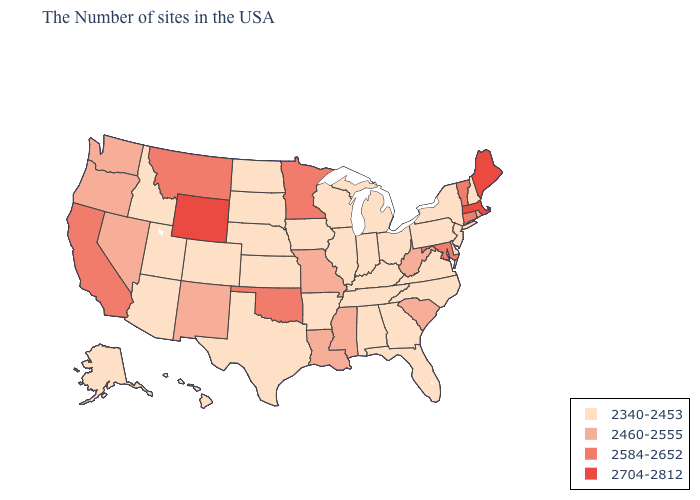Among the states that border Arkansas , which have the highest value?
Concise answer only. Oklahoma. Name the states that have a value in the range 2340-2453?
Concise answer only. New Hampshire, New York, New Jersey, Delaware, Pennsylvania, Virginia, North Carolina, Ohio, Florida, Georgia, Michigan, Kentucky, Indiana, Alabama, Tennessee, Wisconsin, Illinois, Arkansas, Iowa, Kansas, Nebraska, Texas, South Dakota, North Dakota, Colorado, Utah, Arizona, Idaho, Alaska, Hawaii. Which states have the lowest value in the South?
Quick response, please. Delaware, Virginia, North Carolina, Florida, Georgia, Kentucky, Alabama, Tennessee, Arkansas, Texas. Name the states that have a value in the range 2584-2652?
Concise answer only. Vermont, Connecticut, Maryland, Minnesota, Oklahoma, Montana, California. What is the lowest value in states that border Idaho?
Answer briefly. 2340-2453. What is the highest value in the USA?
Be succinct. 2704-2812. Does Georgia have the same value as Nevada?
Quick response, please. No. What is the value of Arkansas?
Short answer required. 2340-2453. What is the lowest value in states that border Utah?
Short answer required. 2340-2453. Name the states that have a value in the range 2704-2812?
Answer briefly. Maine, Massachusetts, Wyoming. What is the value of South Dakota?
Give a very brief answer. 2340-2453. What is the value of Alabama?
Write a very short answer. 2340-2453. What is the value of Indiana?
Short answer required. 2340-2453. Which states hav the highest value in the West?
Write a very short answer. Wyoming. What is the value of Vermont?
Keep it brief. 2584-2652. 